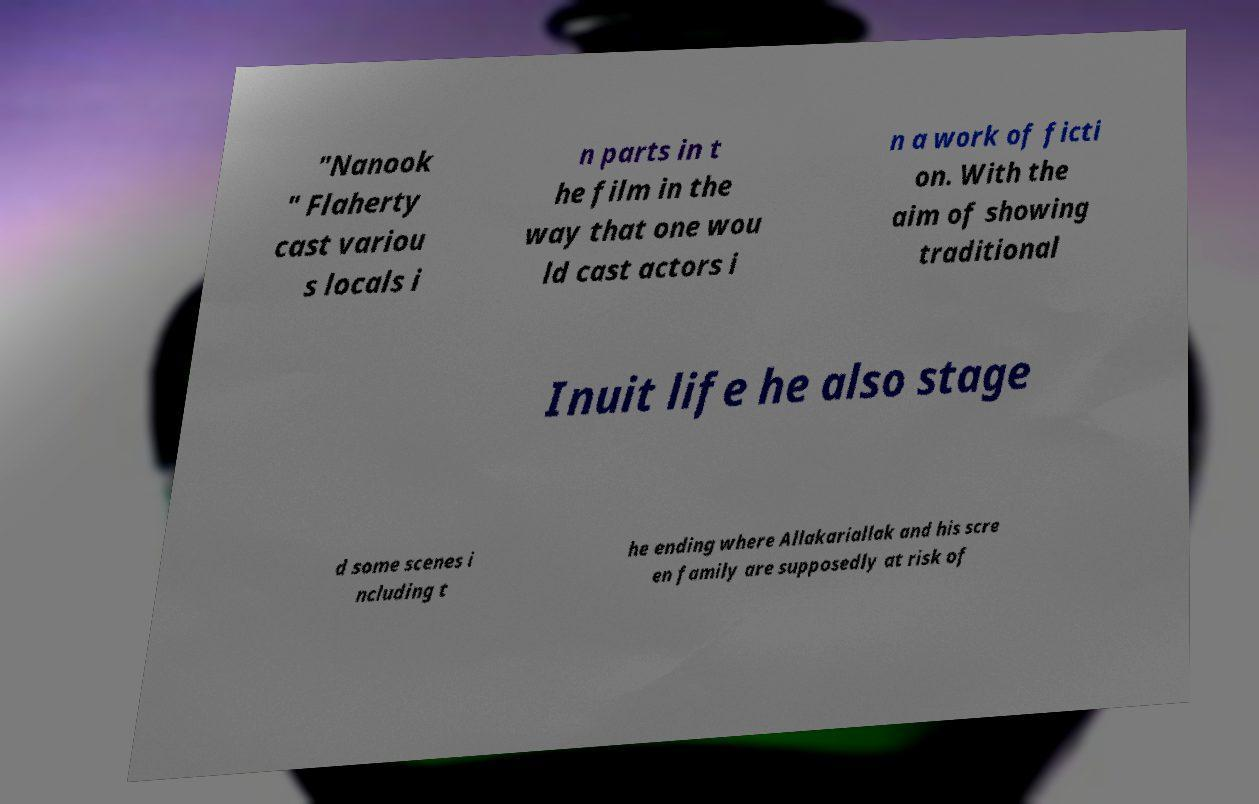Can you accurately transcribe the text from the provided image for me? "Nanook " Flaherty cast variou s locals i n parts in t he film in the way that one wou ld cast actors i n a work of ficti on. With the aim of showing traditional Inuit life he also stage d some scenes i ncluding t he ending where Allakariallak and his scre en family are supposedly at risk of 